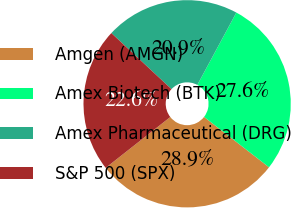Convert chart to OTSL. <chart><loc_0><loc_0><loc_500><loc_500><pie_chart><fcel>Amgen (AMGN)<fcel>Amex Biotech (BTK)<fcel>Amex Pharmaceutical (DRG)<fcel>S&P 500 (SPX)<nl><fcel>28.89%<fcel>27.62%<fcel>20.93%<fcel>22.56%<nl></chart> 